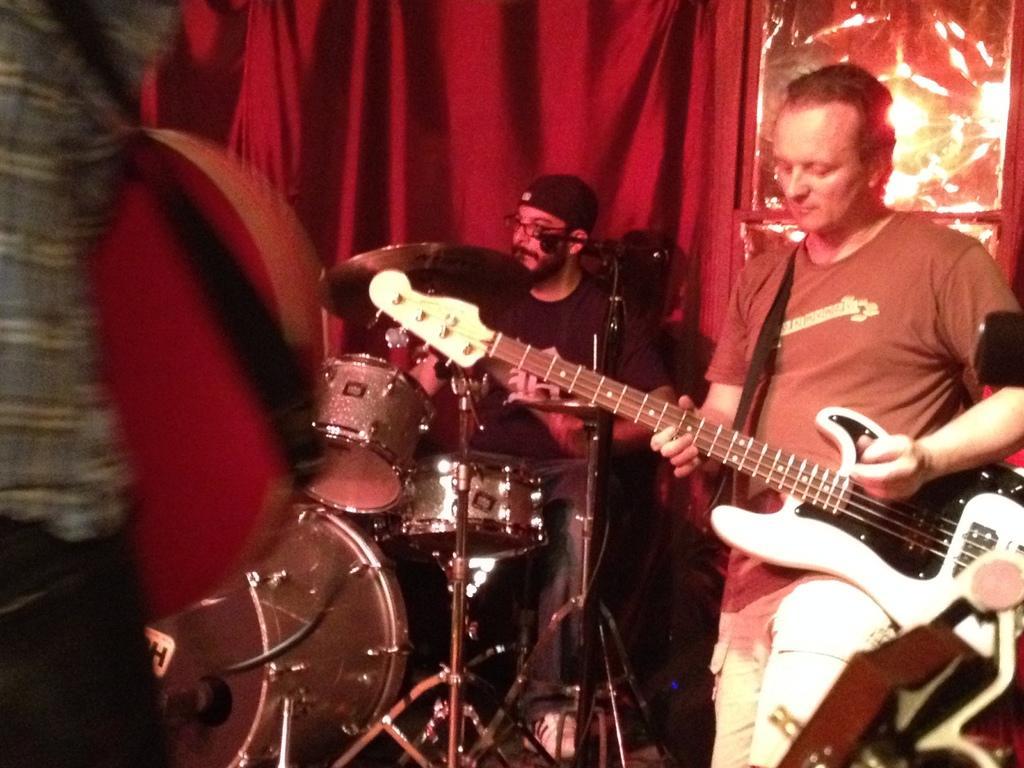Describe this image in one or two sentences. In this image, few peoples are playing a musical instruments. And the middle person wearing a glasses and cap on his head. At the background, we can see red color curtain. 